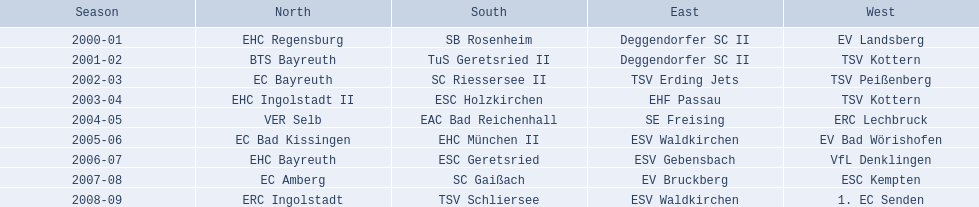Which units were involved in the north? EHC Regensburg, BTS Bayreuth, EC Bayreuth, EHC Ingolstadt II, VER Selb, EC Bad Kissingen, EHC Bayreuth, EC Amberg, ERC Ingolstadt. From these units, which ones engaged in the 2000-2001 period? EHC Regensburg. 